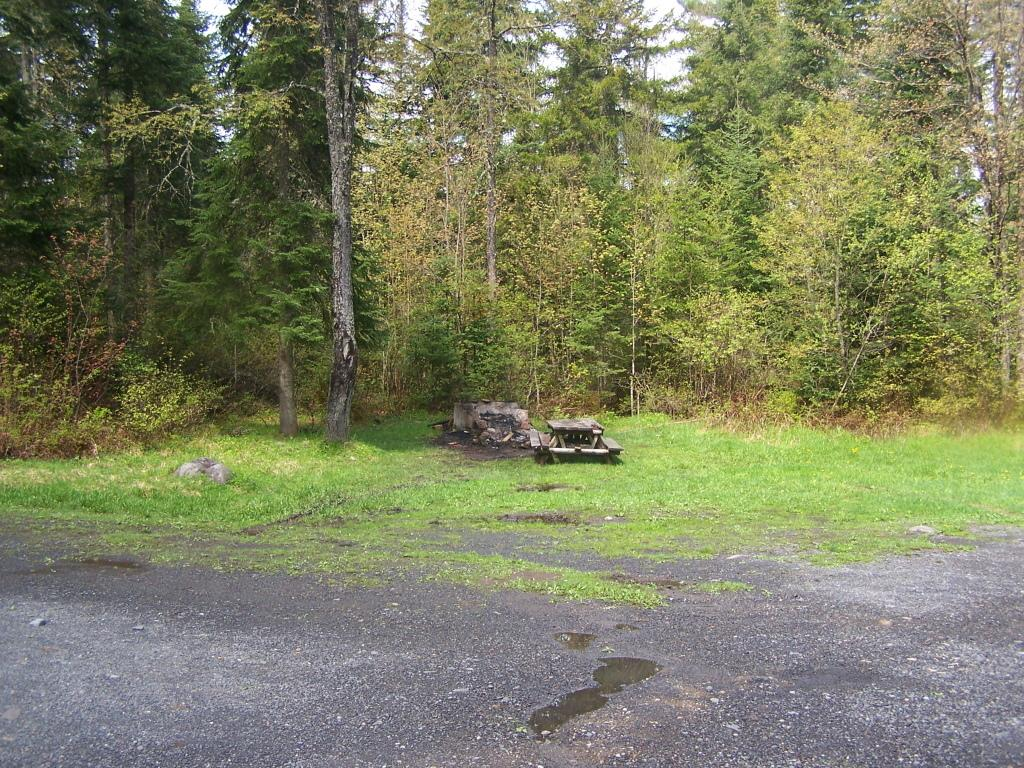What type of seating is present in the image? There is a wooden bench in the image. Where is the bench located? The bench is on the grass. What can be seen in the background of the image? There are many trees in the background of the image. What is visible at the bottom of the image? There is a road visible at the bottom of the image. What natural element is present in the image? Water is visible in the image. What game is being played on the bench in the image? There is no game being played on the bench in the image; it is simply a wooden bench on the grass. 